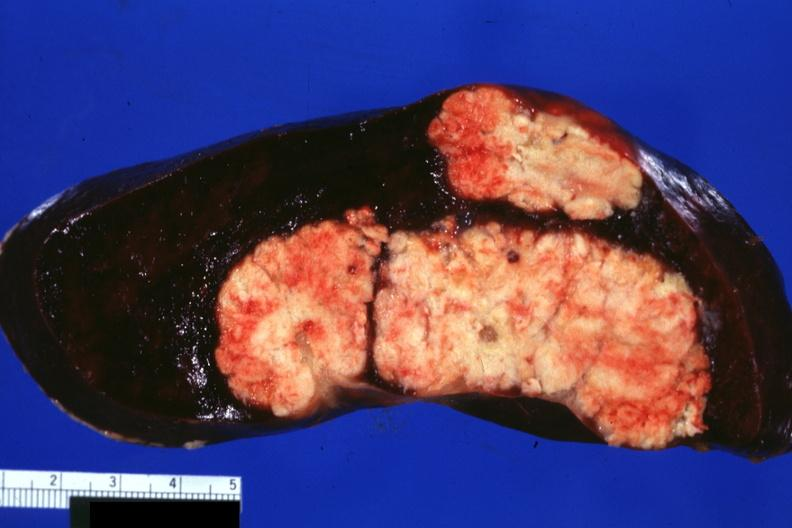what does this image show?
Answer the question using a single word or phrase. Large and very typical metastatic lesions in spleen very well shown 